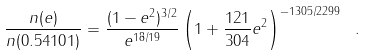<formula> <loc_0><loc_0><loc_500><loc_500>\frac { n ( e ) } { n ( 0 . 5 4 1 0 1 ) } = \frac { ( 1 - e ^ { 2 } ) ^ { 3 / 2 } } { e ^ { 1 8 / 1 9 } } \left ( 1 + \frac { 1 2 1 } { 3 0 4 } e ^ { 2 } \right ) ^ { - 1 3 0 5 / 2 2 9 9 } \ .</formula> 